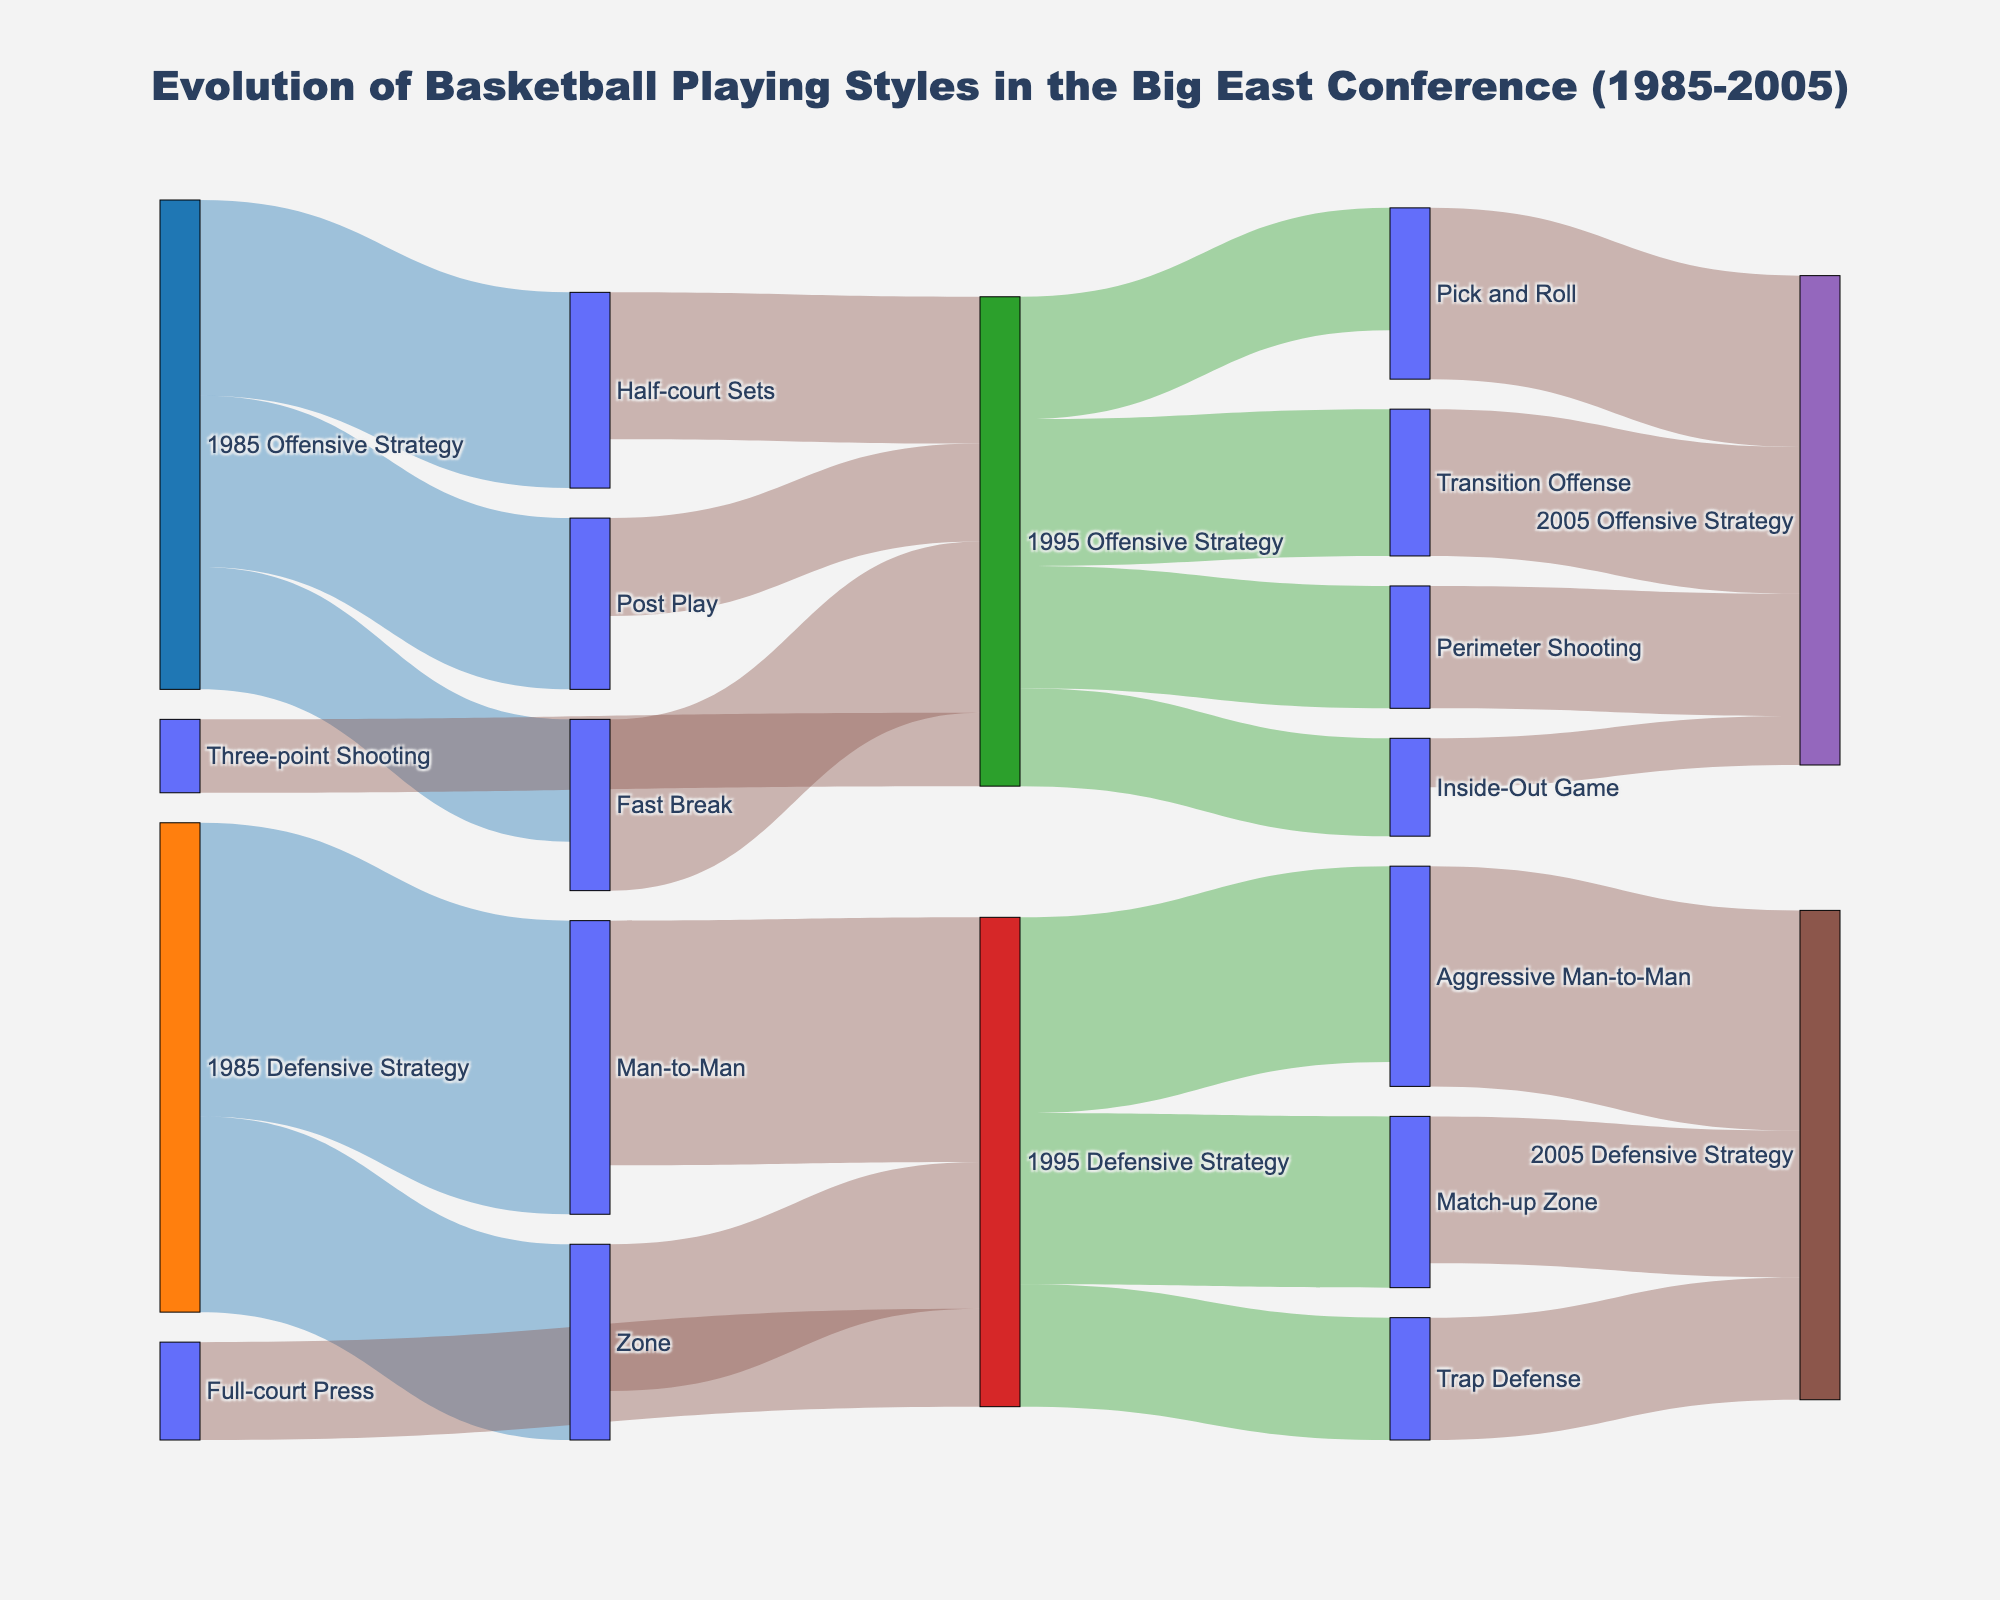What is the title of the Sankey diagram? The title appears at the top of the diagram, clearly stating what the figure represents based on the information provided.
Answer: Evolution of Basketball Playing Styles in the Big East Conference (1985-2005) How many offensive strategies were identified for 1985? By counting the distinct offensive strategies linked from the 1985 Offensive Strategy node, we identify three strategies: Half-court Sets, Fast Break, and Post Play.
Answer: 3 Which 1995 offensive strategy had the highest flow value from the 1985 offensive styles? We need to compare the flow values from 1985 offensive strategies to 1995 offensive strategies and identify the highest value. Fast Break to 1995 Offensive Strategy has the highest flow value of 35.
Answer: Fast Break How many defensive strategies were there in 1995? By counting the defensive strategies linked from the 1995 Defensive Strategy node, we identify three strategies: Aggressive Man-to-Man, Match-up Zone, and Trap Defense.
Answer: 3 How did the use of 'Man-to-Man' defense in 1985 compare to the 'Aggressive Man-to-Man' defense in 1995? We look at the links connecting Man-to-Man in 1985 (value of 60) and Aggressive Man-to-Man in 1995 (value of 50), and compare their values to see the change over time.
Answer: It decreased Which 1995 offensive strategy received contributions from the most number of 1985 offensive strategies? We count the number of links connecting different 1985 offensive strategies to each specific 1995 offensive strategy. Perimeter Shooting in 1995 was sourced from three different 1985 offensive strategies.
Answer: Perimeter Shooting Did the focus on 'Post Play' as an offensive strategy increase or decrease from 1985 to 1995? We compare the flow value of Post Play from 1985 to the sum of its flows into 1995 strategies to determine if it increased or decreased. Post Play decreased from 35 to 20 in 1995.
Answer: Decreased How did the strategy of 'Pick and Roll' evolve from 1995 to 2005? By examining the flow from Pick and Roll in 1995, we see that it evolves to a value of 35 in 2005 strategies.
Answer: Increase Which defensive strategy was introduced in 1995 that was not present in 1985? Observing the unique strategies under 1995 Defensive Strategy that don't appear in 1985, Full-court Press is identified as the new addition.
Answer: Full-court Press What shift can be observed in the defensive strategy emphasis from 1985 to 2005? By comparing the values of defensive strategies over the years, it's noticeable that Aggressive Man-to-Man maintained a significant role, while new strategies like Match-up Zone and Trap Defense appeared by 2005.
Answer: Shift to diversified defensive strategies 